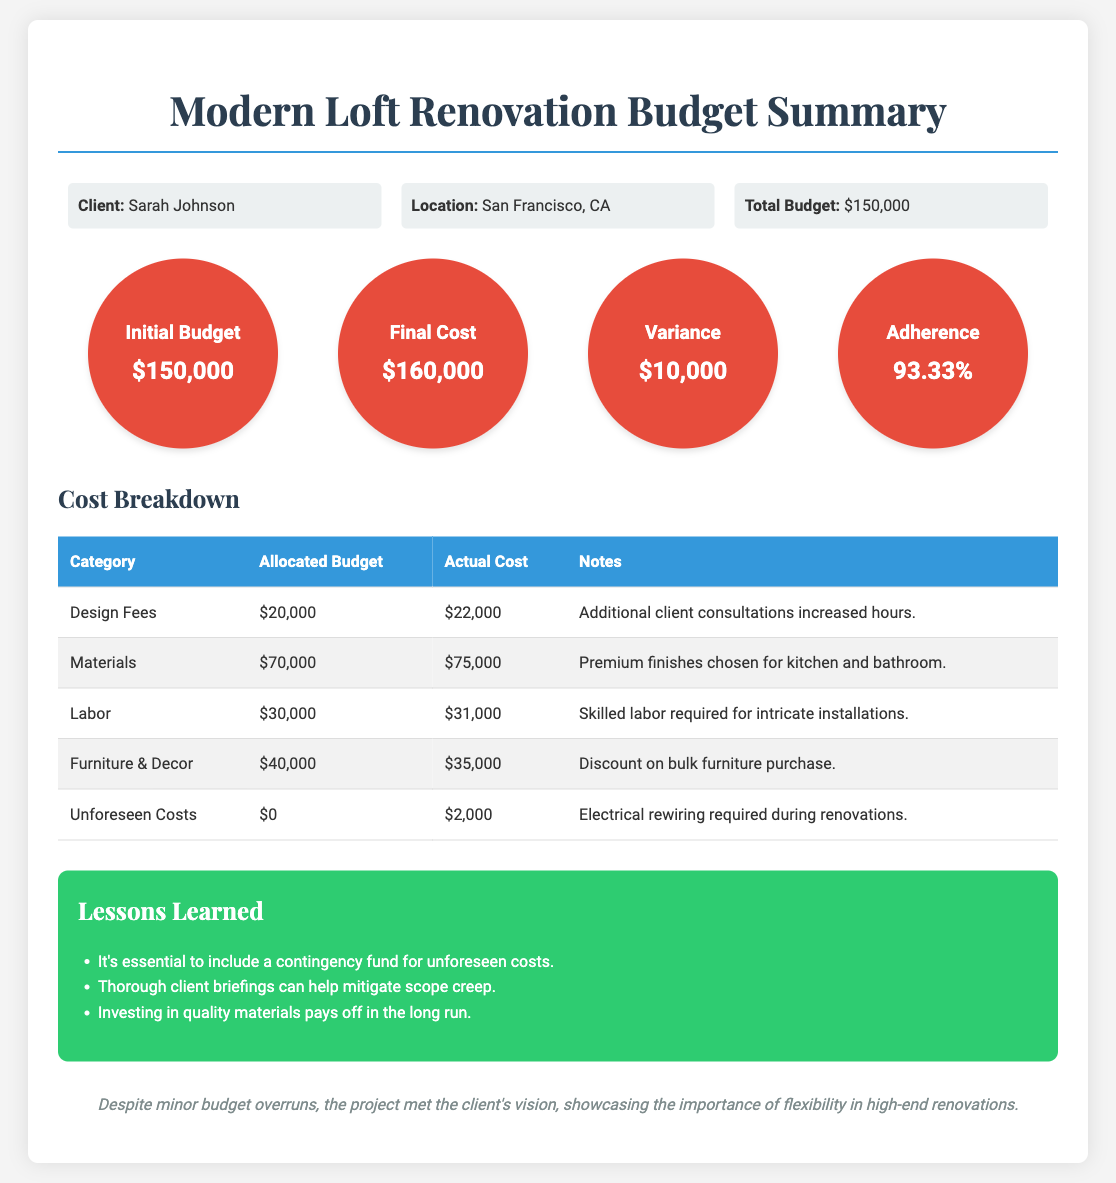What is the client's name? The client's name is provided in the project info section of the document.
Answer: Sarah Johnson What was the total budget for the project? The total budget is stated clearly in the project info section.
Answer: $150,000 What was the final cost of the renovation? The final cost is indicated in the budget summary section.
Answer: $160,000 What category incurred unforeseen costs? The unforeseen costs are detailed in the cost breakdown table of the document.
Answer: Electrical rewiring What is the variance between the initial budget and the final cost? The variance is calculated from the budget summary data provided in the document.
Answer: $10,000 What percentage reflects the budget adherence? The budget adherence percentage is stated in the budget summary section.
Answer: 93.33% How much was allocated for materials? The allocated budget for materials is detailed in the cost breakdown table.
Answer: $70,000 What was the actual cost for labor? The actual cost for labor is presented in the cost breakdown table.
Answer: $31,000 What lesson emphasizes the importance of a contingency fund? The lessons learned section highlights this lesson specifically.
Answer: It's essential to include a contingency fund for unforeseen costs 